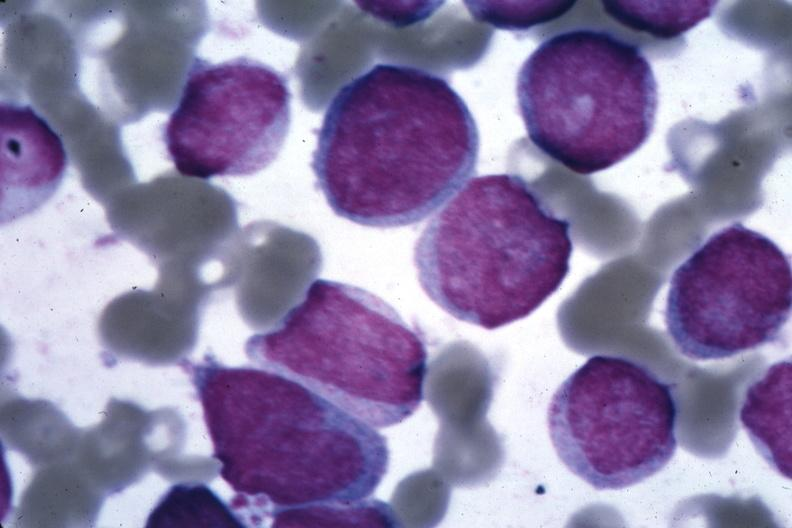s infarction secondary to shock present?
Answer the question using a single word or phrase. No 